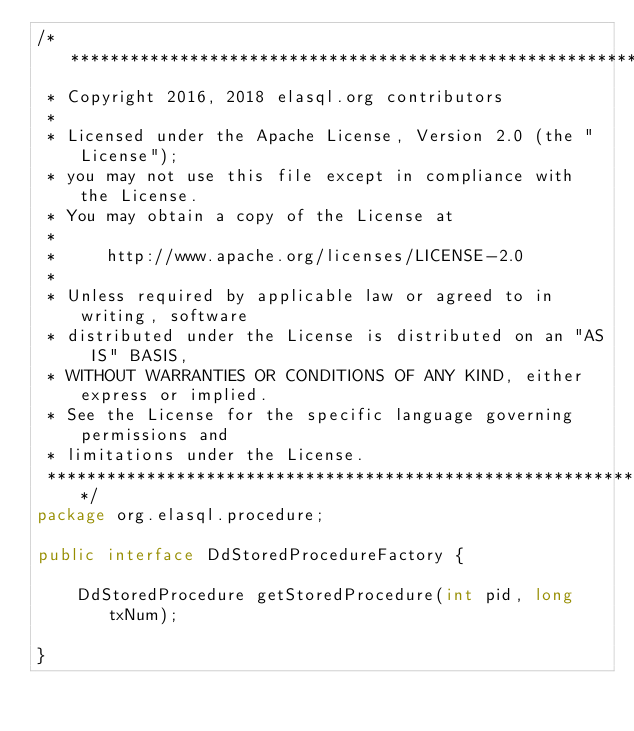Convert code to text. <code><loc_0><loc_0><loc_500><loc_500><_Java_>/*******************************************************************************
 * Copyright 2016, 2018 elasql.org contributors
 *
 * Licensed under the Apache License, Version 2.0 (the "License");
 * you may not use this file except in compliance with the License.
 * You may obtain a copy of the License at
 *
 *     http://www.apache.org/licenses/LICENSE-2.0
 *
 * Unless required by applicable law or agreed to in writing, software
 * distributed under the License is distributed on an "AS IS" BASIS,
 * WITHOUT WARRANTIES OR CONDITIONS OF ANY KIND, either express or implied.
 * See the License for the specific language governing permissions and
 * limitations under the License.
 *******************************************************************************/
package org.elasql.procedure;

public interface DdStoredProcedureFactory {

	DdStoredProcedure getStoredProcedure(int pid, long txNum);

}
</code> 